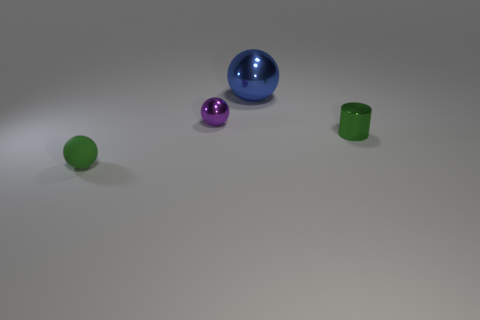Subtract all big blue shiny balls. How many balls are left? 2 Add 1 small balls. How many objects exist? 5 Subtract 2 balls. How many balls are left? 1 Subtract all balls. How many objects are left? 1 Subtract all blue spheres. How many spheres are left? 2 Subtract all brown spheres. Subtract all blue cylinders. How many spheres are left? 3 Subtract all purple matte balls. Subtract all tiny green matte things. How many objects are left? 3 Add 4 cylinders. How many cylinders are left? 5 Add 1 blue metal things. How many blue metal things exist? 2 Subtract 0 yellow balls. How many objects are left? 4 